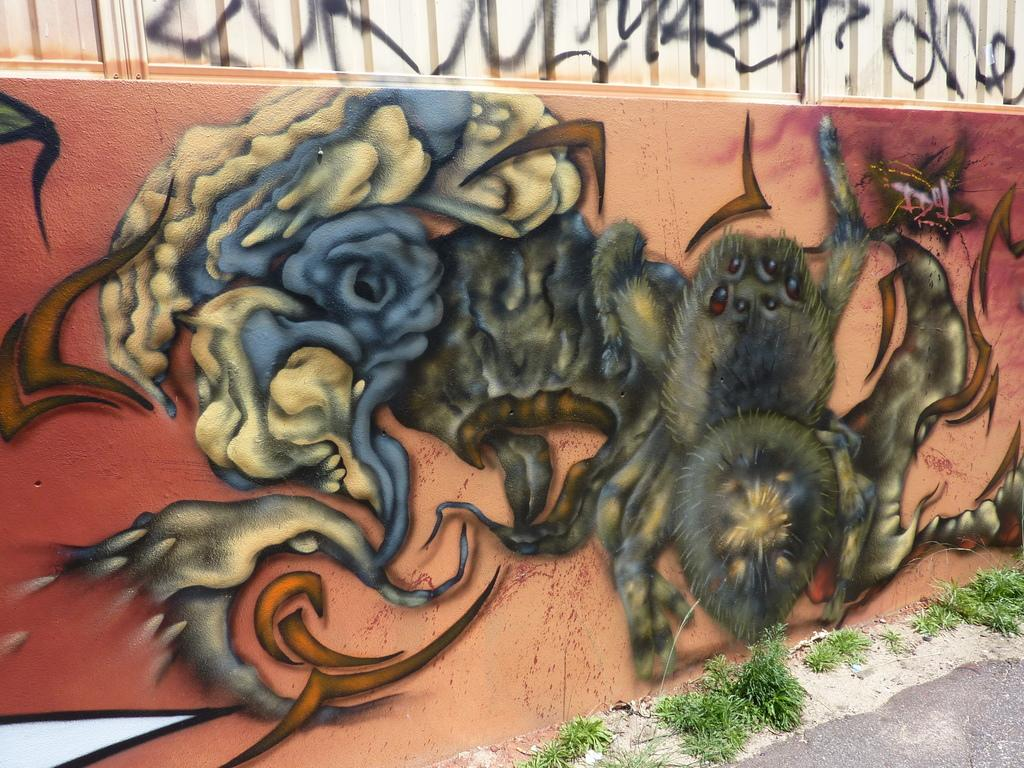What is present on the wall in the image? The wall has a painting on it. How many cattle can be seen in the painting on the wall? There is no information about cattle in the image or the painting on the wall. 